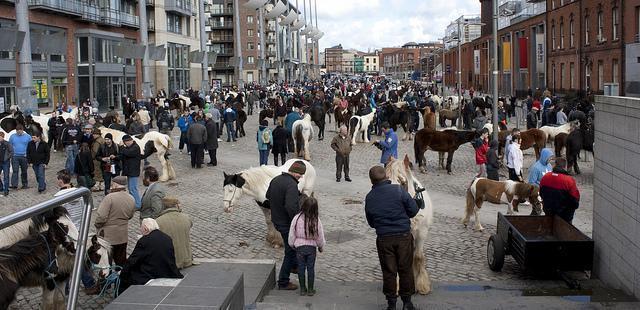What animal are the people checking out?
Pick the right solution, then justify: 'Answer: answer
Rationale: rationale.'
Options: Goats, lambs, donkeys, horses. Answer: horses.
Rationale: The other options aren't in the picture. 